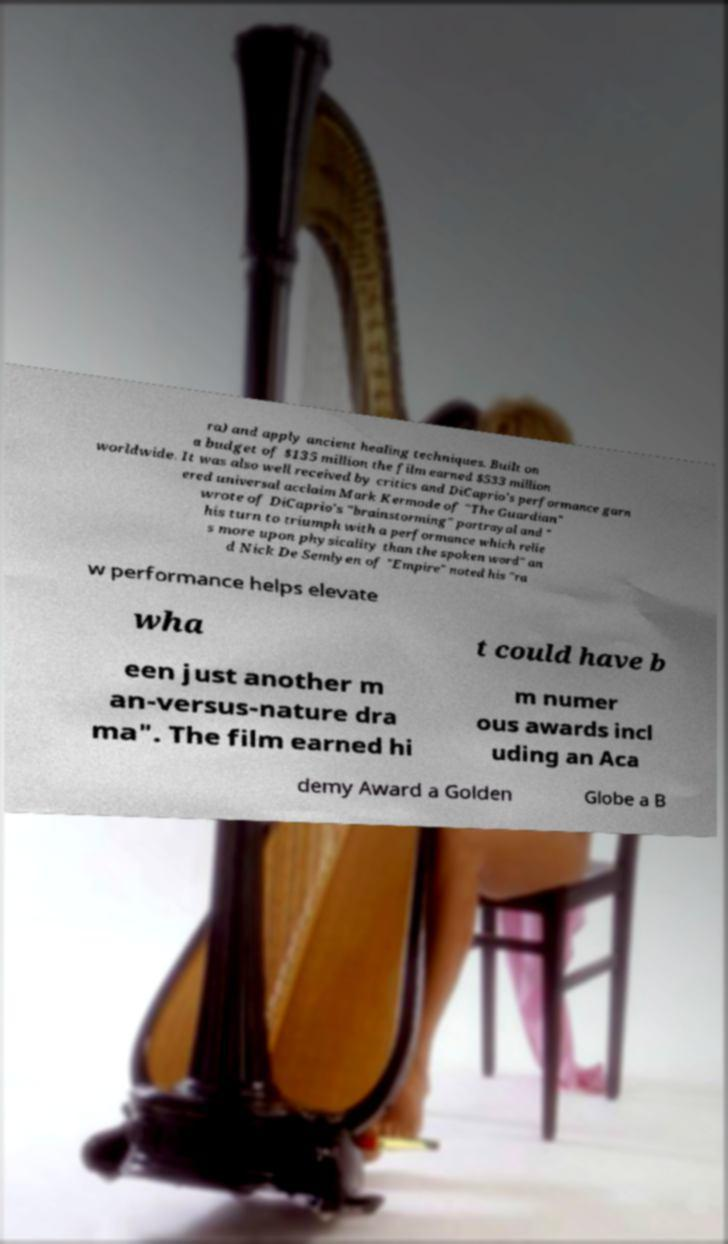Please read and relay the text visible in this image. What does it say? ra) and apply ancient healing techniques. Built on a budget of $135 million the film earned $533 million worldwide. It was also well received by critics and DiCaprio's performance garn ered universal acclaim Mark Kermode of "The Guardian" wrote of DiCaprio's "brainstorming" portrayal and " his turn to triumph with a performance which relie s more upon physicality than the spoken word" an d Nick De Semlyen of "Empire" noted his "ra w performance helps elevate wha t could have b een just another m an-versus-nature dra ma". The film earned hi m numer ous awards incl uding an Aca demy Award a Golden Globe a B 